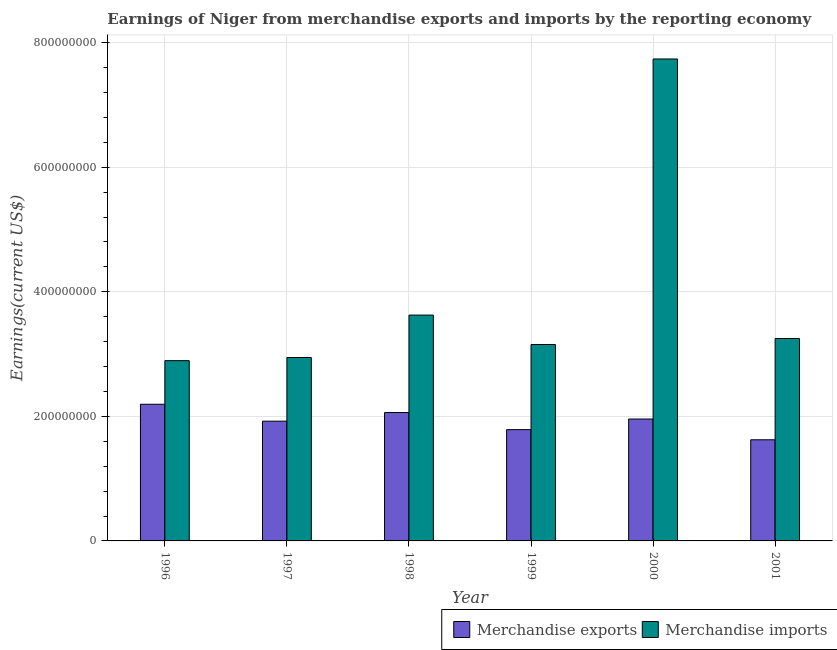How many groups of bars are there?
Make the answer very short. 6. Are the number of bars per tick equal to the number of legend labels?
Make the answer very short. Yes. Are the number of bars on each tick of the X-axis equal?
Your answer should be very brief. Yes. How many bars are there on the 5th tick from the left?
Make the answer very short. 2. What is the label of the 3rd group of bars from the left?
Your response must be concise. 1998. What is the earnings from merchandise exports in 1998?
Provide a succinct answer. 2.06e+08. Across all years, what is the maximum earnings from merchandise imports?
Provide a short and direct response. 7.74e+08. Across all years, what is the minimum earnings from merchandise imports?
Offer a terse response. 2.89e+08. What is the total earnings from merchandise imports in the graph?
Offer a very short reply. 2.36e+09. What is the difference between the earnings from merchandise exports in 1998 and that in 2000?
Give a very brief answer. 1.04e+07. What is the difference between the earnings from merchandise imports in 1997 and the earnings from merchandise exports in 1998?
Keep it short and to the point. -6.81e+07. What is the average earnings from merchandise imports per year?
Give a very brief answer. 3.93e+08. In the year 1997, what is the difference between the earnings from merchandise imports and earnings from merchandise exports?
Your answer should be very brief. 0. What is the ratio of the earnings from merchandise imports in 1998 to that in 2000?
Your answer should be very brief. 0.47. Is the earnings from merchandise exports in 2000 less than that in 2001?
Provide a succinct answer. No. What is the difference between the highest and the second highest earnings from merchandise imports?
Your response must be concise. 4.11e+08. What is the difference between the highest and the lowest earnings from merchandise exports?
Make the answer very short. 5.70e+07. What does the 2nd bar from the left in 2000 represents?
Your answer should be compact. Merchandise imports. What does the 1st bar from the right in 2000 represents?
Ensure brevity in your answer.  Merchandise imports. How many years are there in the graph?
Offer a terse response. 6. What is the difference between two consecutive major ticks on the Y-axis?
Your answer should be compact. 2.00e+08. Are the values on the major ticks of Y-axis written in scientific E-notation?
Your response must be concise. No. How many legend labels are there?
Give a very brief answer. 2. How are the legend labels stacked?
Make the answer very short. Horizontal. What is the title of the graph?
Keep it short and to the point. Earnings of Niger from merchandise exports and imports by the reporting economy. Does "Electricity and heat production" appear as one of the legend labels in the graph?
Provide a short and direct response. No. What is the label or title of the Y-axis?
Keep it short and to the point. Earnings(current US$). What is the Earnings(current US$) in Merchandise exports in 1996?
Your response must be concise. 2.19e+08. What is the Earnings(current US$) of Merchandise imports in 1996?
Offer a terse response. 2.89e+08. What is the Earnings(current US$) in Merchandise exports in 1997?
Your response must be concise. 1.92e+08. What is the Earnings(current US$) in Merchandise imports in 1997?
Your answer should be compact. 2.94e+08. What is the Earnings(current US$) in Merchandise exports in 1998?
Offer a very short reply. 2.06e+08. What is the Earnings(current US$) in Merchandise imports in 1998?
Offer a very short reply. 3.63e+08. What is the Earnings(current US$) in Merchandise exports in 1999?
Give a very brief answer. 1.79e+08. What is the Earnings(current US$) in Merchandise imports in 1999?
Provide a short and direct response. 3.15e+08. What is the Earnings(current US$) of Merchandise exports in 2000?
Your response must be concise. 1.96e+08. What is the Earnings(current US$) in Merchandise imports in 2000?
Provide a succinct answer. 7.74e+08. What is the Earnings(current US$) of Merchandise exports in 2001?
Provide a succinct answer. 1.62e+08. What is the Earnings(current US$) of Merchandise imports in 2001?
Give a very brief answer. 3.25e+08. Across all years, what is the maximum Earnings(current US$) of Merchandise exports?
Your response must be concise. 2.19e+08. Across all years, what is the maximum Earnings(current US$) in Merchandise imports?
Keep it short and to the point. 7.74e+08. Across all years, what is the minimum Earnings(current US$) in Merchandise exports?
Give a very brief answer. 1.62e+08. Across all years, what is the minimum Earnings(current US$) of Merchandise imports?
Your response must be concise. 2.89e+08. What is the total Earnings(current US$) of Merchandise exports in the graph?
Keep it short and to the point. 1.15e+09. What is the total Earnings(current US$) of Merchandise imports in the graph?
Your response must be concise. 2.36e+09. What is the difference between the Earnings(current US$) of Merchandise exports in 1996 and that in 1997?
Provide a succinct answer. 2.72e+07. What is the difference between the Earnings(current US$) of Merchandise imports in 1996 and that in 1997?
Your answer should be very brief. -5.08e+06. What is the difference between the Earnings(current US$) in Merchandise exports in 1996 and that in 1998?
Your response must be concise. 1.33e+07. What is the difference between the Earnings(current US$) in Merchandise imports in 1996 and that in 1998?
Keep it short and to the point. -7.32e+07. What is the difference between the Earnings(current US$) in Merchandise exports in 1996 and that in 1999?
Your answer should be compact. 4.07e+07. What is the difference between the Earnings(current US$) in Merchandise imports in 1996 and that in 1999?
Provide a short and direct response. -2.59e+07. What is the difference between the Earnings(current US$) in Merchandise exports in 1996 and that in 2000?
Make the answer very short. 2.37e+07. What is the difference between the Earnings(current US$) of Merchandise imports in 1996 and that in 2000?
Give a very brief answer. -4.84e+08. What is the difference between the Earnings(current US$) of Merchandise exports in 1996 and that in 2001?
Keep it short and to the point. 5.70e+07. What is the difference between the Earnings(current US$) of Merchandise imports in 1996 and that in 2001?
Your answer should be compact. -3.56e+07. What is the difference between the Earnings(current US$) in Merchandise exports in 1997 and that in 1998?
Keep it short and to the point. -1.39e+07. What is the difference between the Earnings(current US$) of Merchandise imports in 1997 and that in 1998?
Keep it short and to the point. -6.81e+07. What is the difference between the Earnings(current US$) in Merchandise exports in 1997 and that in 1999?
Offer a very short reply. 1.36e+07. What is the difference between the Earnings(current US$) of Merchandise imports in 1997 and that in 1999?
Your response must be concise. -2.08e+07. What is the difference between the Earnings(current US$) in Merchandise exports in 1997 and that in 2000?
Offer a very short reply. -3.47e+06. What is the difference between the Earnings(current US$) in Merchandise imports in 1997 and that in 2000?
Your response must be concise. -4.79e+08. What is the difference between the Earnings(current US$) of Merchandise exports in 1997 and that in 2001?
Provide a short and direct response. 2.99e+07. What is the difference between the Earnings(current US$) in Merchandise imports in 1997 and that in 2001?
Offer a very short reply. -3.05e+07. What is the difference between the Earnings(current US$) of Merchandise exports in 1998 and that in 1999?
Your response must be concise. 2.74e+07. What is the difference between the Earnings(current US$) in Merchandise imports in 1998 and that in 1999?
Offer a terse response. 4.73e+07. What is the difference between the Earnings(current US$) of Merchandise exports in 1998 and that in 2000?
Provide a succinct answer. 1.04e+07. What is the difference between the Earnings(current US$) of Merchandise imports in 1998 and that in 2000?
Provide a short and direct response. -4.11e+08. What is the difference between the Earnings(current US$) of Merchandise exports in 1998 and that in 2001?
Offer a very short reply. 4.37e+07. What is the difference between the Earnings(current US$) of Merchandise imports in 1998 and that in 2001?
Ensure brevity in your answer.  3.76e+07. What is the difference between the Earnings(current US$) in Merchandise exports in 1999 and that in 2000?
Make the answer very short. -1.71e+07. What is the difference between the Earnings(current US$) of Merchandise imports in 1999 and that in 2000?
Make the answer very short. -4.58e+08. What is the difference between the Earnings(current US$) of Merchandise exports in 1999 and that in 2001?
Ensure brevity in your answer.  1.63e+07. What is the difference between the Earnings(current US$) in Merchandise imports in 1999 and that in 2001?
Offer a terse response. -9.69e+06. What is the difference between the Earnings(current US$) in Merchandise exports in 2000 and that in 2001?
Make the answer very short. 3.33e+07. What is the difference between the Earnings(current US$) in Merchandise imports in 2000 and that in 2001?
Your answer should be very brief. 4.49e+08. What is the difference between the Earnings(current US$) of Merchandise exports in 1996 and the Earnings(current US$) of Merchandise imports in 1997?
Give a very brief answer. -7.51e+07. What is the difference between the Earnings(current US$) in Merchandise exports in 1996 and the Earnings(current US$) in Merchandise imports in 1998?
Your answer should be compact. -1.43e+08. What is the difference between the Earnings(current US$) in Merchandise exports in 1996 and the Earnings(current US$) in Merchandise imports in 1999?
Your answer should be very brief. -9.59e+07. What is the difference between the Earnings(current US$) in Merchandise exports in 1996 and the Earnings(current US$) in Merchandise imports in 2000?
Offer a very short reply. -5.54e+08. What is the difference between the Earnings(current US$) of Merchandise exports in 1996 and the Earnings(current US$) of Merchandise imports in 2001?
Provide a short and direct response. -1.06e+08. What is the difference between the Earnings(current US$) in Merchandise exports in 1997 and the Earnings(current US$) in Merchandise imports in 1998?
Your response must be concise. -1.70e+08. What is the difference between the Earnings(current US$) in Merchandise exports in 1997 and the Earnings(current US$) in Merchandise imports in 1999?
Offer a very short reply. -1.23e+08. What is the difference between the Earnings(current US$) in Merchandise exports in 1997 and the Earnings(current US$) in Merchandise imports in 2000?
Your answer should be very brief. -5.82e+08. What is the difference between the Earnings(current US$) in Merchandise exports in 1997 and the Earnings(current US$) in Merchandise imports in 2001?
Make the answer very short. -1.33e+08. What is the difference between the Earnings(current US$) of Merchandise exports in 1998 and the Earnings(current US$) of Merchandise imports in 1999?
Offer a very short reply. -1.09e+08. What is the difference between the Earnings(current US$) of Merchandise exports in 1998 and the Earnings(current US$) of Merchandise imports in 2000?
Offer a terse response. -5.68e+08. What is the difference between the Earnings(current US$) in Merchandise exports in 1998 and the Earnings(current US$) in Merchandise imports in 2001?
Your response must be concise. -1.19e+08. What is the difference between the Earnings(current US$) of Merchandise exports in 1999 and the Earnings(current US$) of Merchandise imports in 2000?
Ensure brevity in your answer.  -5.95e+08. What is the difference between the Earnings(current US$) of Merchandise exports in 1999 and the Earnings(current US$) of Merchandise imports in 2001?
Make the answer very short. -1.46e+08. What is the difference between the Earnings(current US$) of Merchandise exports in 2000 and the Earnings(current US$) of Merchandise imports in 2001?
Offer a terse response. -1.29e+08. What is the average Earnings(current US$) in Merchandise exports per year?
Keep it short and to the point. 1.92e+08. What is the average Earnings(current US$) in Merchandise imports per year?
Ensure brevity in your answer.  3.93e+08. In the year 1996, what is the difference between the Earnings(current US$) of Merchandise exports and Earnings(current US$) of Merchandise imports?
Your answer should be compact. -7.00e+07. In the year 1997, what is the difference between the Earnings(current US$) of Merchandise exports and Earnings(current US$) of Merchandise imports?
Ensure brevity in your answer.  -1.02e+08. In the year 1998, what is the difference between the Earnings(current US$) of Merchandise exports and Earnings(current US$) of Merchandise imports?
Make the answer very short. -1.56e+08. In the year 1999, what is the difference between the Earnings(current US$) of Merchandise exports and Earnings(current US$) of Merchandise imports?
Ensure brevity in your answer.  -1.37e+08. In the year 2000, what is the difference between the Earnings(current US$) of Merchandise exports and Earnings(current US$) of Merchandise imports?
Offer a terse response. -5.78e+08. In the year 2001, what is the difference between the Earnings(current US$) of Merchandise exports and Earnings(current US$) of Merchandise imports?
Your response must be concise. -1.63e+08. What is the ratio of the Earnings(current US$) in Merchandise exports in 1996 to that in 1997?
Give a very brief answer. 1.14. What is the ratio of the Earnings(current US$) of Merchandise imports in 1996 to that in 1997?
Make the answer very short. 0.98. What is the ratio of the Earnings(current US$) in Merchandise exports in 1996 to that in 1998?
Your answer should be compact. 1.06. What is the ratio of the Earnings(current US$) of Merchandise imports in 1996 to that in 1998?
Keep it short and to the point. 0.8. What is the ratio of the Earnings(current US$) of Merchandise exports in 1996 to that in 1999?
Provide a short and direct response. 1.23. What is the ratio of the Earnings(current US$) of Merchandise imports in 1996 to that in 1999?
Provide a short and direct response. 0.92. What is the ratio of the Earnings(current US$) of Merchandise exports in 1996 to that in 2000?
Offer a very short reply. 1.12. What is the ratio of the Earnings(current US$) of Merchandise imports in 1996 to that in 2000?
Provide a short and direct response. 0.37. What is the ratio of the Earnings(current US$) of Merchandise exports in 1996 to that in 2001?
Provide a short and direct response. 1.35. What is the ratio of the Earnings(current US$) in Merchandise imports in 1996 to that in 2001?
Make the answer very short. 0.89. What is the ratio of the Earnings(current US$) of Merchandise exports in 1997 to that in 1998?
Provide a short and direct response. 0.93. What is the ratio of the Earnings(current US$) in Merchandise imports in 1997 to that in 1998?
Offer a terse response. 0.81. What is the ratio of the Earnings(current US$) of Merchandise exports in 1997 to that in 1999?
Your answer should be compact. 1.08. What is the ratio of the Earnings(current US$) of Merchandise imports in 1997 to that in 1999?
Make the answer very short. 0.93. What is the ratio of the Earnings(current US$) in Merchandise exports in 1997 to that in 2000?
Provide a short and direct response. 0.98. What is the ratio of the Earnings(current US$) in Merchandise imports in 1997 to that in 2000?
Provide a short and direct response. 0.38. What is the ratio of the Earnings(current US$) in Merchandise exports in 1997 to that in 2001?
Your answer should be compact. 1.18. What is the ratio of the Earnings(current US$) in Merchandise imports in 1997 to that in 2001?
Your answer should be very brief. 0.91. What is the ratio of the Earnings(current US$) of Merchandise exports in 1998 to that in 1999?
Give a very brief answer. 1.15. What is the ratio of the Earnings(current US$) in Merchandise imports in 1998 to that in 1999?
Keep it short and to the point. 1.15. What is the ratio of the Earnings(current US$) in Merchandise exports in 1998 to that in 2000?
Ensure brevity in your answer.  1.05. What is the ratio of the Earnings(current US$) in Merchandise imports in 1998 to that in 2000?
Your answer should be compact. 0.47. What is the ratio of the Earnings(current US$) in Merchandise exports in 1998 to that in 2001?
Provide a succinct answer. 1.27. What is the ratio of the Earnings(current US$) in Merchandise imports in 1998 to that in 2001?
Ensure brevity in your answer.  1.12. What is the ratio of the Earnings(current US$) of Merchandise exports in 1999 to that in 2000?
Your answer should be very brief. 0.91. What is the ratio of the Earnings(current US$) in Merchandise imports in 1999 to that in 2000?
Ensure brevity in your answer.  0.41. What is the ratio of the Earnings(current US$) in Merchandise exports in 1999 to that in 2001?
Your answer should be very brief. 1.1. What is the ratio of the Earnings(current US$) of Merchandise imports in 1999 to that in 2001?
Provide a succinct answer. 0.97. What is the ratio of the Earnings(current US$) of Merchandise exports in 2000 to that in 2001?
Make the answer very short. 1.21. What is the ratio of the Earnings(current US$) in Merchandise imports in 2000 to that in 2001?
Your answer should be compact. 2.38. What is the difference between the highest and the second highest Earnings(current US$) in Merchandise exports?
Your answer should be compact. 1.33e+07. What is the difference between the highest and the second highest Earnings(current US$) in Merchandise imports?
Your response must be concise. 4.11e+08. What is the difference between the highest and the lowest Earnings(current US$) of Merchandise exports?
Your response must be concise. 5.70e+07. What is the difference between the highest and the lowest Earnings(current US$) in Merchandise imports?
Your answer should be compact. 4.84e+08. 